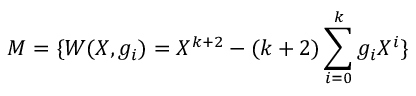<formula> <loc_0><loc_0><loc_500><loc_500>M = \{ W ( X , g _ { i } ) = X ^ { k + 2 } - ( k + 2 ) \sum _ { i = 0 } ^ { k } g _ { i } X ^ { i } \}</formula> 